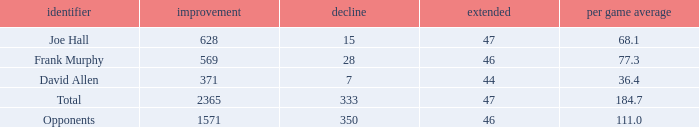How much Loss has a Gain smaller than 1571, and a Long smaller than 47, and an Avg/G of 36.4? 1.0. 